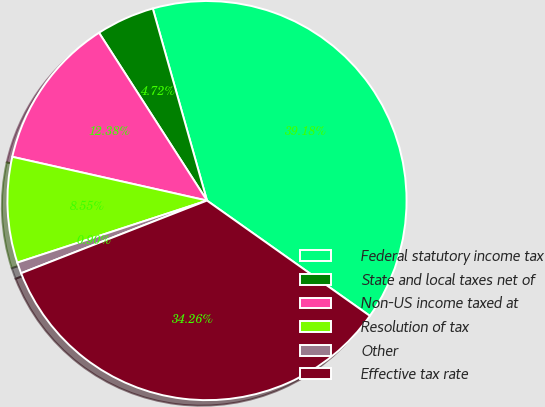<chart> <loc_0><loc_0><loc_500><loc_500><pie_chart><fcel>Federal statutory income tax<fcel>State and local taxes net of<fcel>Non-US income taxed at<fcel>Resolution of tax<fcel>Other<fcel>Effective tax rate<nl><fcel>39.18%<fcel>4.72%<fcel>12.38%<fcel>8.55%<fcel>0.9%<fcel>34.26%<nl></chart> 